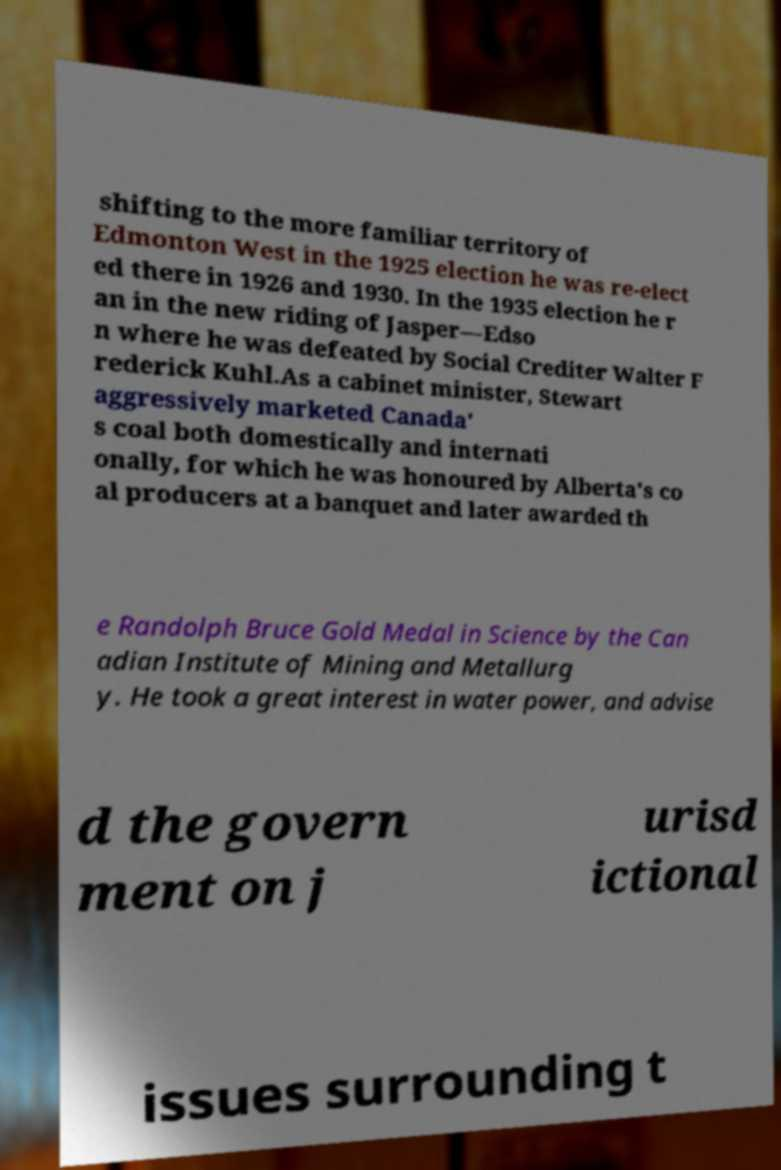Can you read and provide the text displayed in the image?This photo seems to have some interesting text. Can you extract and type it out for me? shifting to the more familiar territory of Edmonton West in the 1925 election he was re-elect ed there in 1926 and 1930. In the 1935 election he r an in the new riding of Jasper—Edso n where he was defeated by Social Crediter Walter F rederick Kuhl.As a cabinet minister, Stewart aggressively marketed Canada' s coal both domestically and internati onally, for which he was honoured by Alberta's co al producers at a banquet and later awarded th e Randolph Bruce Gold Medal in Science by the Can adian Institute of Mining and Metallurg y. He took a great interest in water power, and advise d the govern ment on j urisd ictional issues surrounding t 